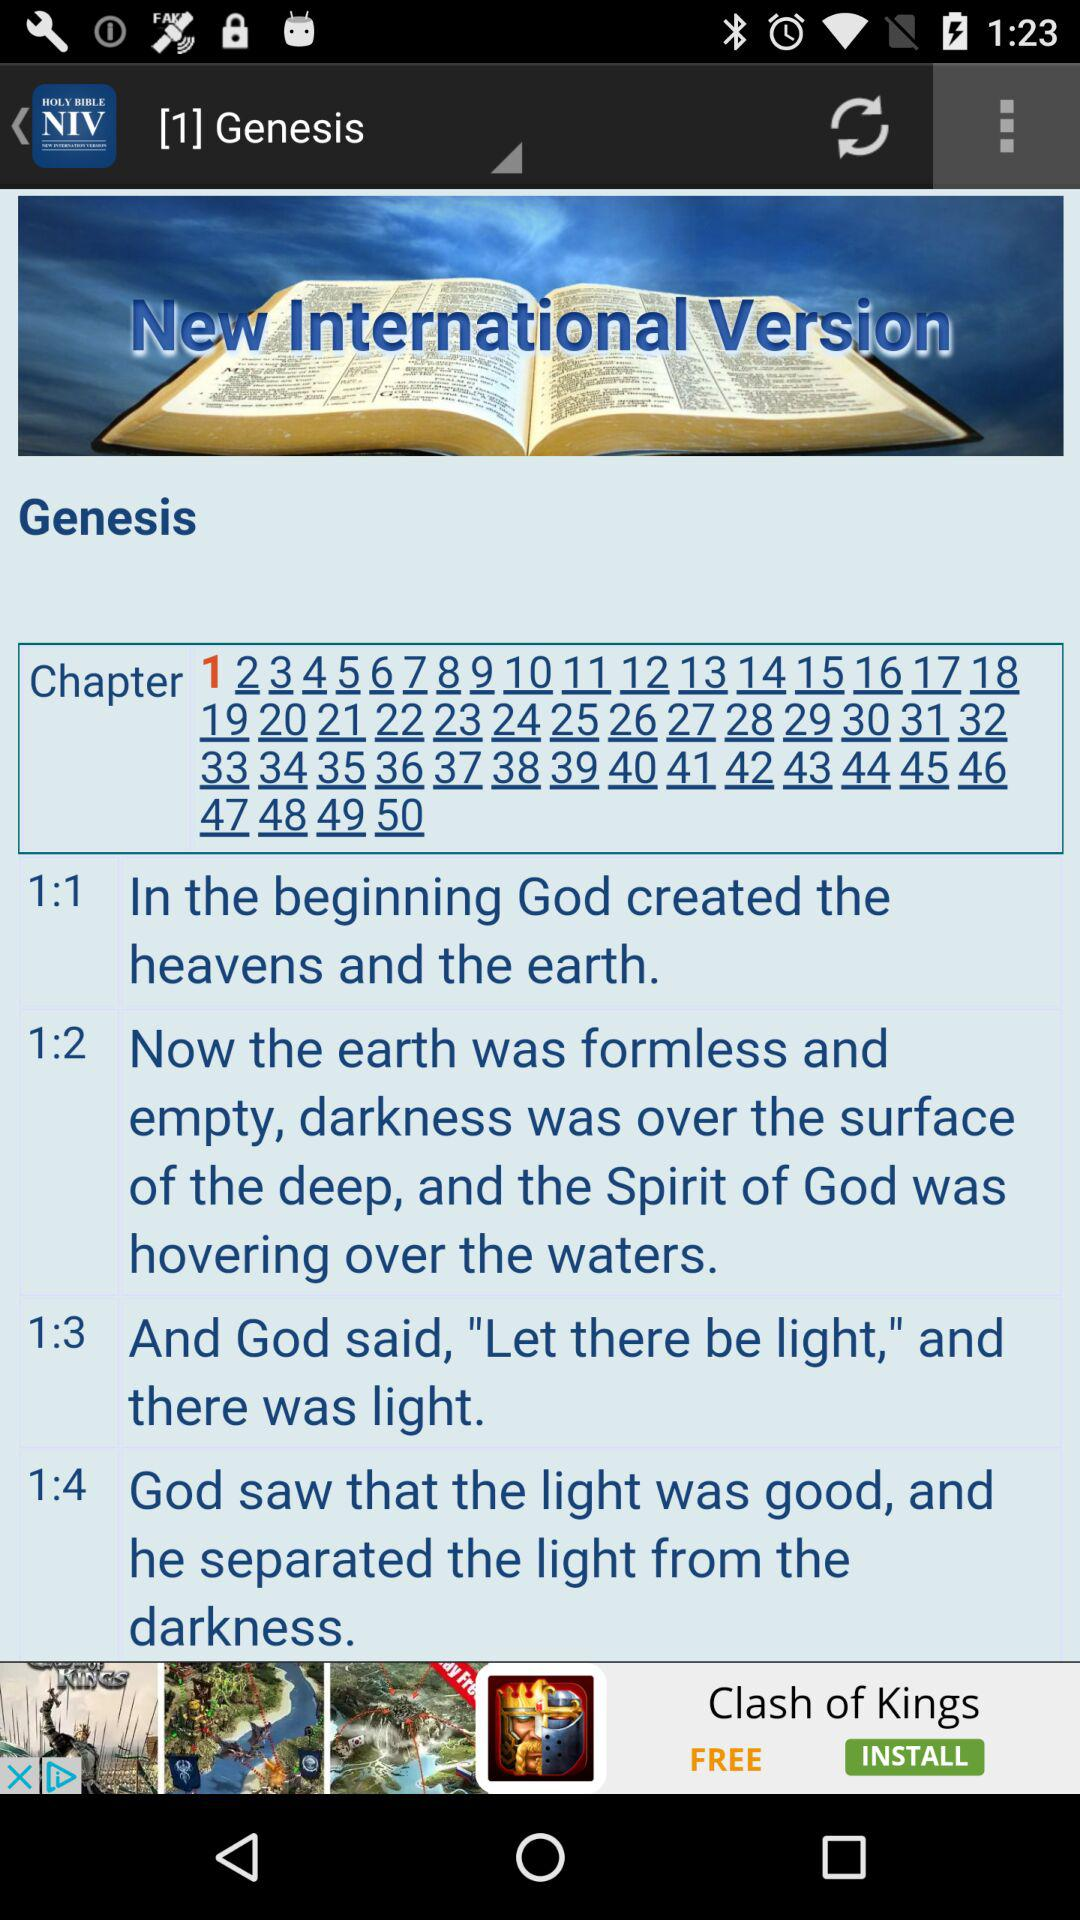How many chapters are in this book?
Answer the question using a single word or phrase. 50 